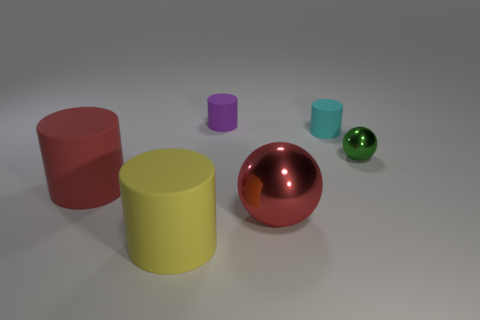What number of tiny rubber things have the same color as the big sphere?
Provide a succinct answer. 0. There is a green sphere; does it have the same size as the red object left of the large red shiny object?
Give a very brief answer. No. There is a matte object to the left of the big matte cylinder in front of the red object that is behind the large sphere; what is its size?
Your answer should be compact. Large. There is a red shiny sphere; what number of cyan cylinders are in front of it?
Give a very brief answer. 0. There is a large cylinder in front of the cylinder on the left side of the yellow object; what is its material?
Provide a short and direct response. Rubber. Is there any other thing that is the same size as the cyan rubber cylinder?
Offer a terse response. Yes. Does the red metallic object have the same size as the green sphere?
Your response must be concise. No. How many objects are cylinders that are to the left of the yellow matte thing or tiny objects that are to the left of the tiny green metal ball?
Ensure brevity in your answer.  3. Is the number of tiny metal objects left of the cyan rubber object greater than the number of shiny things?
Give a very brief answer. No. How many other things are there of the same shape as the big red shiny thing?
Ensure brevity in your answer.  1. 